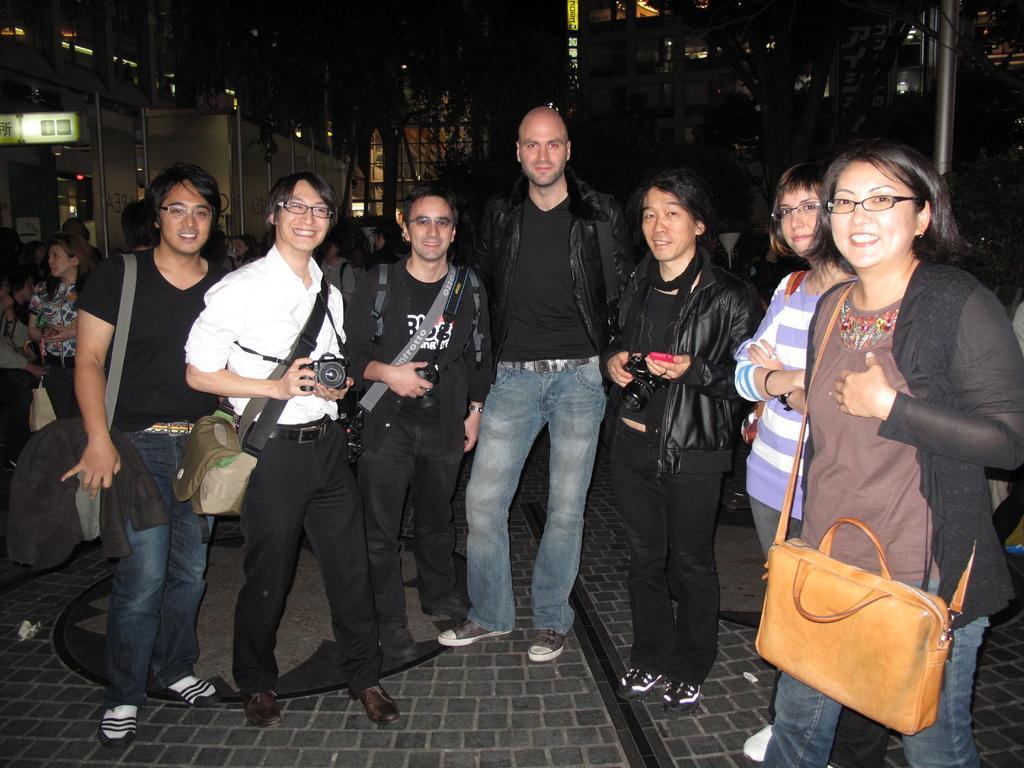Please provide a concise description of this image. In this image I can see number of people are standing. I can also see smile on their faces. Here I can see a person is holding a camera. 